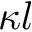Convert formula to latex. <formula><loc_0><loc_0><loc_500><loc_500>\kappa l</formula> 